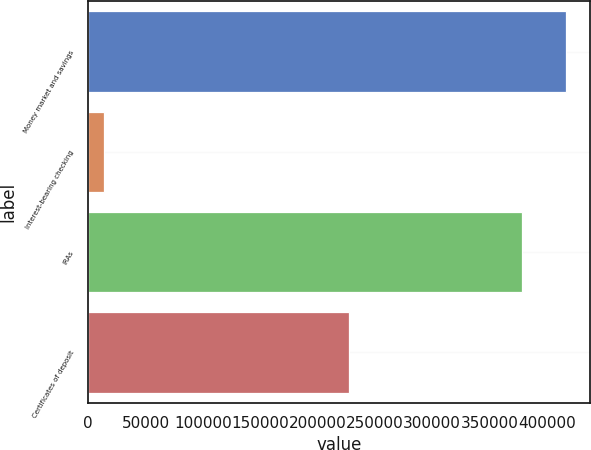<chart> <loc_0><loc_0><loc_500><loc_500><bar_chart><fcel>Money market and savings<fcel>Interest-bearing checking<fcel>IRAs<fcel>Certificates of deposit<nl><fcel>416697<fcel>13677<fcel>377973<fcel>227094<nl></chart> 